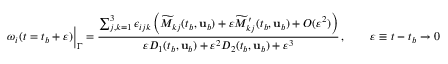<formula> <loc_0><loc_0><loc_500><loc_500>\omega _ { i } ( t = t _ { b } + \varepsilon ) \Big | _ { \Gamma } = \frac { \sum _ { j , k = 1 } ^ { 3 } \epsilon _ { i j k } \left ( \widetilde { M } _ { k j } ( t _ { b } , { u } _ { b } ) + \varepsilon \widetilde { M } _ { k j } ^ { \prime } ( t _ { b } , { u } _ { b } ) + O ( \varepsilon ^ { 2 } ) \right ) } { \varepsilon D _ { 1 } ( t _ { b } , { u } _ { b } ) + \varepsilon ^ { 2 } D _ { 2 } ( t _ { b } , { u } _ { b } ) + \varepsilon ^ { 3 } } \, , \quad \varepsilon \equiv t - t _ { b } \to 0</formula> 